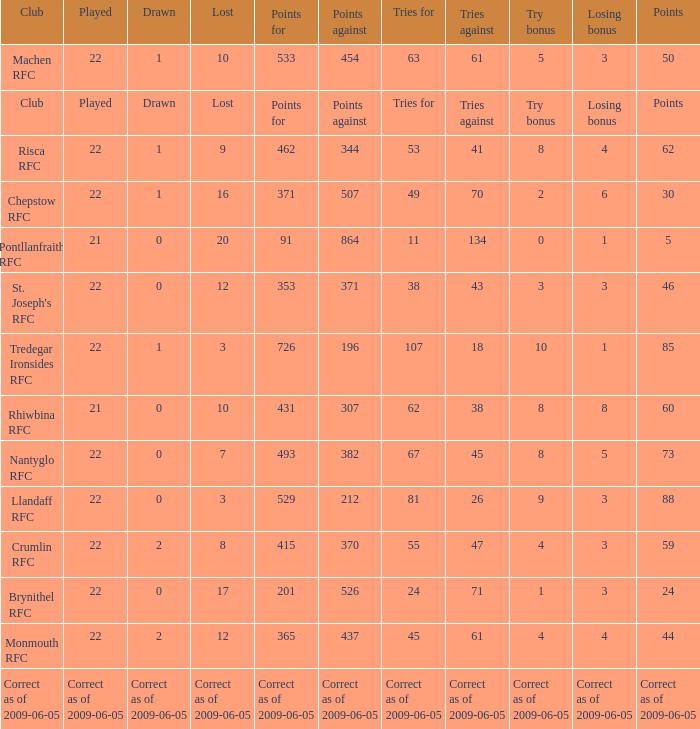If the losing bonus was 6, what is the tries for? 49.0. 